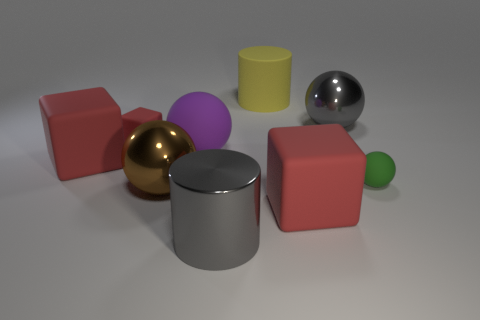There is a shiny ball that is in front of the small green rubber sphere; what is its color?
Offer a very short reply. Brown. How many green balls are there?
Give a very brief answer. 1. The large yellow object that is the same material as the purple thing is what shape?
Keep it short and to the point. Cylinder. Do the tiny rubber object that is right of the purple thing and the large cube left of the brown sphere have the same color?
Make the answer very short. No. Are there an equal number of gray spheres that are right of the big brown ball and large purple rubber things?
Keep it short and to the point. Yes. There is a large yellow thing; what number of things are behind it?
Make the answer very short. 0. The green matte object has what size?
Provide a short and direct response. Small. What color is the ball that is made of the same material as the green object?
Make the answer very short. Purple. How many other spheres are the same size as the gray ball?
Provide a succinct answer. 2. Is the material of the red object that is on the right side of the big rubber ball the same as the small ball?
Provide a short and direct response. Yes. 